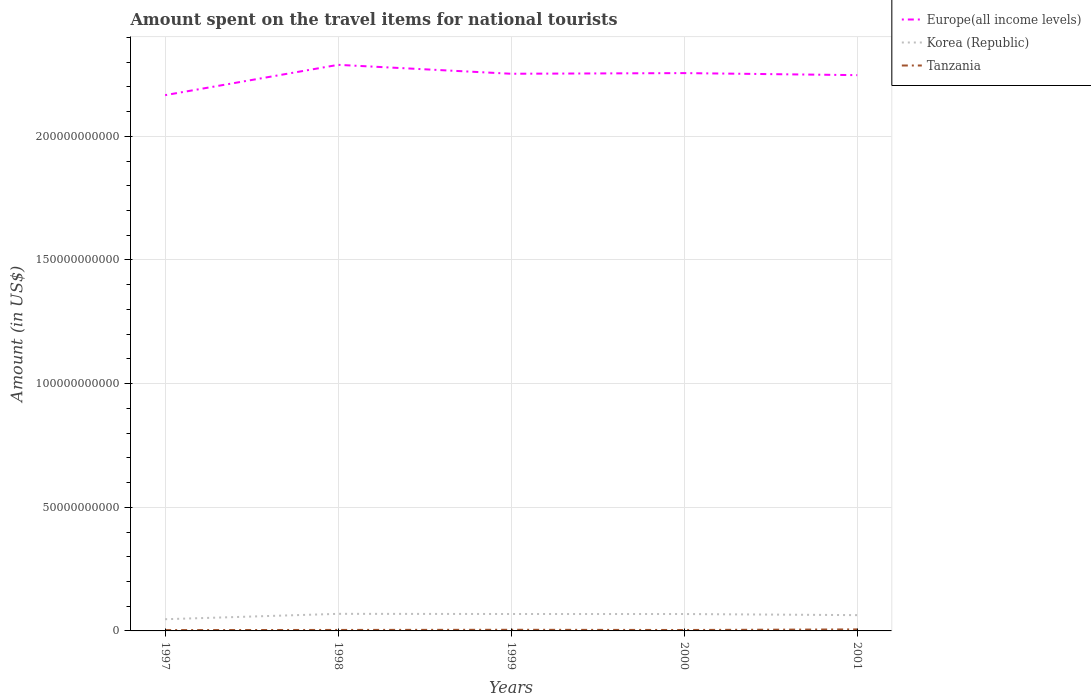Does the line corresponding to Korea (Republic) intersect with the line corresponding to Europe(all income levels)?
Your answer should be very brief. No. Is the number of lines equal to the number of legend labels?
Your answer should be compact. Yes. Across all years, what is the maximum amount spent on the travel items for national tourists in Tanzania?
Keep it short and to the point. 3.39e+08. In which year was the amount spent on the travel items for national tourists in Korea (Republic) maximum?
Provide a succinct answer. 1997. What is the total amount spent on the travel items for national tourists in Tanzania in the graph?
Ensure brevity in your answer.  -1.51e+08. What is the difference between the highest and the second highest amount spent on the travel items for national tourists in Korea (Republic)?
Make the answer very short. 2.18e+09. How many lines are there?
Your response must be concise. 3. What is the difference between two consecutive major ticks on the Y-axis?
Offer a very short reply. 5.00e+1. Are the values on the major ticks of Y-axis written in scientific E-notation?
Offer a terse response. No. Does the graph contain grids?
Provide a short and direct response. Yes. How are the legend labels stacked?
Give a very brief answer. Vertical. What is the title of the graph?
Offer a very short reply. Amount spent on the travel items for national tourists. Does "Slovenia" appear as one of the legend labels in the graph?
Provide a succinct answer. No. What is the Amount (in US$) of Europe(all income levels) in 1997?
Your response must be concise. 2.17e+11. What is the Amount (in US$) of Korea (Republic) in 1997?
Ensure brevity in your answer.  4.73e+09. What is the Amount (in US$) in Tanzania in 1997?
Make the answer very short. 3.39e+08. What is the Amount (in US$) of Europe(all income levels) in 1998?
Offer a very short reply. 2.29e+11. What is the Amount (in US$) in Korea (Republic) in 1998?
Your answer should be very brief. 6.91e+09. What is the Amount (in US$) in Tanzania in 1998?
Your answer should be compact. 3.99e+08. What is the Amount (in US$) in Europe(all income levels) in 1999?
Offer a terse response. 2.25e+11. What is the Amount (in US$) of Korea (Republic) in 1999?
Offer a very short reply. 6.84e+09. What is the Amount (in US$) in Tanzania in 1999?
Provide a short and direct response. 4.64e+08. What is the Amount (in US$) of Europe(all income levels) in 2000?
Offer a very short reply. 2.26e+11. What is the Amount (in US$) of Korea (Republic) in 2000?
Your response must be concise. 6.83e+09. What is the Amount (in US$) in Tanzania in 2000?
Offer a very short reply. 3.77e+08. What is the Amount (in US$) in Europe(all income levels) in 2001?
Ensure brevity in your answer.  2.25e+11. What is the Amount (in US$) in Korea (Republic) in 2001?
Your answer should be very brief. 6.38e+09. What is the Amount (in US$) in Tanzania in 2001?
Keep it short and to the point. 6.15e+08. Across all years, what is the maximum Amount (in US$) of Europe(all income levels)?
Ensure brevity in your answer.  2.29e+11. Across all years, what is the maximum Amount (in US$) in Korea (Republic)?
Your answer should be very brief. 6.91e+09. Across all years, what is the maximum Amount (in US$) in Tanzania?
Offer a very short reply. 6.15e+08. Across all years, what is the minimum Amount (in US$) of Europe(all income levels)?
Keep it short and to the point. 2.17e+11. Across all years, what is the minimum Amount (in US$) in Korea (Republic)?
Your response must be concise. 4.73e+09. Across all years, what is the minimum Amount (in US$) in Tanzania?
Your answer should be very brief. 3.39e+08. What is the total Amount (in US$) of Europe(all income levels) in the graph?
Offer a very short reply. 1.12e+12. What is the total Amount (in US$) in Korea (Republic) in the graph?
Offer a very short reply. 3.17e+1. What is the total Amount (in US$) in Tanzania in the graph?
Offer a very short reply. 2.19e+09. What is the difference between the Amount (in US$) of Europe(all income levels) in 1997 and that in 1998?
Offer a terse response. -1.23e+1. What is the difference between the Amount (in US$) of Korea (Republic) in 1997 and that in 1998?
Offer a very short reply. -2.18e+09. What is the difference between the Amount (in US$) of Tanzania in 1997 and that in 1998?
Provide a succinct answer. -6.00e+07. What is the difference between the Amount (in US$) of Europe(all income levels) in 1997 and that in 1999?
Offer a terse response. -8.65e+09. What is the difference between the Amount (in US$) of Korea (Republic) in 1997 and that in 1999?
Offer a very short reply. -2.11e+09. What is the difference between the Amount (in US$) of Tanzania in 1997 and that in 1999?
Provide a short and direct response. -1.25e+08. What is the difference between the Amount (in US$) in Europe(all income levels) in 1997 and that in 2000?
Your response must be concise. -8.92e+09. What is the difference between the Amount (in US$) in Korea (Republic) in 1997 and that in 2000?
Provide a short and direct response. -2.10e+09. What is the difference between the Amount (in US$) of Tanzania in 1997 and that in 2000?
Your answer should be compact. -3.80e+07. What is the difference between the Amount (in US$) of Europe(all income levels) in 1997 and that in 2001?
Offer a terse response. -8.09e+09. What is the difference between the Amount (in US$) in Korea (Republic) in 1997 and that in 2001?
Keep it short and to the point. -1.65e+09. What is the difference between the Amount (in US$) in Tanzania in 1997 and that in 2001?
Your response must be concise. -2.76e+08. What is the difference between the Amount (in US$) of Europe(all income levels) in 1998 and that in 1999?
Provide a succinct answer. 3.61e+09. What is the difference between the Amount (in US$) of Korea (Republic) in 1998 and that in 1999?
Provide a succinct answer. 6.70e+07. What is the difference between the Amount (in US$) of Tanzania in 1998 and that in 1999?
Keep it short and to the point. -6.50e+07. What is the difference between the Amount (in US$) in Europe(all income levels) in 1998 and that in 2000?
Offer a very short reply. 3.34e+09. What is the difference between the Amount (in US$) of Korea (Republic) in 1998 and that in 2000?
Give a very brief answer. 7.40e+07. What is the difference between the Amount (in US$) of Tanzania in 1998 and that in 2000?
Ensure brevity in your answer.  2.20e+07. What is the difference between the Amount (in US$) of Europe(all income levels) in 1998 and that in 2001?
Ensure brevity in your answer.  4.17e+09. What is the difference between the Amount (in US$) of Korea (Republic) in 1998 and that in 2001?
Keep it short and to the point. 5.24e+08. What is the difference between the Amount (in US$) in Tanzania in 1998 and that in 2001?
Give a very brief answer. -2.16e+08. What is the difference between the Amount (in US$) of Europe(all income levels) in 1999 and that in 2000?
Make the answer very short. -2.67e+08. What is the difference between the Amount (in US$) of Korea (Republic) in 1999 and that in 2000?
Your answer should be very brief. 7.00e+06. What is the difference between the Amount (in US$) in Tanzania in 1999 and that in 2000?
Offer a very short reply. 8.70e+07. What is the difference between the Amount (in US$) in Europe(all income levels) in 1999 and that in 2001?
Ensure brevity in your answer.  5.62e+08. What is the difference between the Amount (in US$) in Korea (Republic) in 1999 and that in 2001?
Offer a terse response. 4.57e+08. What is the difference between the Amount (in US$) in Tanzania in 1999 and that in 2001?
Provide a short and direct response. -1.51e+08. What is the difference between the Amount (in US$) in Europe(all income levels) in 2000 and that in 2001?
Your answer should be very brief. 8.29e+08. What is the difference between the Amount (in US$) of Korea (Republic) in 2000 and that in 2001?
Make the answer very short. 4.50e+08. What is the difference between the Amount (in US$) of Tanzania in 2000 and that in 2001?
Ensure brevity in your answer.  -2.38e+08. What is the difference between the Amount (in US$) of Europe(all income levels) in 1997 and the Amount (in US$) of Korea (Republic) in 1998?
Keep it short and to the point. 2.10e+11. What is the difference between the Amount (in US$) in Europe(all income levels) in 1997 and the Amount (in US$) in Tanzania in 1998?
Give a very brief answer. 2.16e+11. What is the difference between the Amount (in US$) in Korea (Republic) in 1997 and the Amount (in US$) in Tanzania in 1998?
Give a very brief answer. 4.33e+09. What is the difference between the Amount (in US$) of Europe(all income levels) in 1997 and the Amount (in US$) of Korea (Republic) in 1999?
Provide a succinct answer. 2.10e+11. What is the difference between the Amount (in US$) of Europe(all income levels) in 1997 and the Amount (in US$) of Tanzania in 1999?
Make the answer very short. 2.16e+11. What is the difference between the Amount (in US$) in Korea (Republic) in 1997 and the Amount (in US$) in Tanzania in 1999?
Ensure brevity in your answer.  4.27e+09. What is the difference between the Amount (in US$) of Europe(all income levels) in 1997 and the Amount (in US$) of Korea (Republic) in 2000?
Make the answer very short. 2.10e+11. What is the difference between the Amount (in US$) in Europe(all income levels) in 1997 and the Amount (in US$) in Tanzania in 2000?
Offer a very short reply. 2.16e+11. What is the difference between the Amount (in US$) in Korea (Republic) in 1997 and the Amount (in US$) in Tanzania in 2000?
Provide a succinct answer. 4.35e+09. What is the difference between the Amount (in US$) of Europe(all income levels) in 1997 and the Amount (in US$) of Korea (Republic) in 2001?
Provide a succinct answer. 2.10e+11. What is the difference between the Amount (in US$) in Europe(all income levels) in 1997 and the Amount (in US$) in Tanzania in 2001?
Your answer should be compact. 2.16e+11. What is the difference between the Amount (in US$) in Korea (Republic) in 1997 and the Amount (in US$) in Tanzania in 2001?
Offer a terse response. 4.12e+09. What is the difference between the Amount (in US$) in Europe(all income levels) in 1998 and the Amount (in US$) in Korea (Republic) in 1999?
Make the answer very short. 2.22e+11. What is the difference between the Amount (in US$) in Europe(all income levels) in 1998 and the Amount (in US$) in Tanzania in 1999?
Provide a succinct answer. 2.28e+11. What is the difference between the Amount (in US$) of Korea (Republic) in 1998 and the Amount (in US$) of Tanzania in 1999?
Provide a short and direct response. 6.44e+09. What is the difference between the Amount (in US$) in Europe(all income levels) in 1998 and the Amount (in US$) in Korea (Republic) in 2000?
Provide a succinct answer. 2.22e+11. What is the difference between the Amount (in US$) in Europe(all income levels) in 1998 and the Amount (in US$) in Tanzania in 2000?
Make the answer very short. 2.29e+11. What is the difference between the Amount (in US$) of Korea (Republic) in 1998 and the Amount (in US$) of Tanzania in 2000?
Ensure brevity in your answer.  6.53e+09. What is the difference between the Amount (in US$) in Europe(all income levels) in 1998 and the Amount (in US$) in Korea (Republic) in 2001?
Keep it short and to the point. 2.23e+11. What is the difference between the Amount (in US$) of Europe(all income levels) in 1998 and the Amount (in US$) of Tanzania in 2001?
Make the answer very short. 2.28e+11. What is the difference between the Amount (in US$) of Korea (Republic) in 1998 and the Amount (in US$) of Tanzania in 2001?
Your response must be concise. 6.29e+09. What is the difference between the Amount (in US$) in Europe(all income levels) in 1999 and the Amount (in US$) in Korea (Republic) in 2000?
Your answer should be very brief. 2.18e+11. What is the difference between the Amount (in US$) in Europe(all income levels) in 1999 and the Amount (in US$) in Tanzania in 2000?
Offer a very short reply. 2.25e+11. What is the difference between the Amount (in US$) in Korea (Republic) in 1999 and the Amount (in US$) in Tanzania in 2000?
Ensure brevity in your answer.  6.46e+09. What is the difference between the Amount (in US$) of Europe(all income levels) in 1999 and the Amount (in US$) of Korea (Republic) in 2001?
Offer a very short reply. 2.19e+11. What is the difference between the Amount (in US$) of Europe(all income levels) in 1999 and the Amount (in US$) of Tanzania in 2001?
Offer a very short reply. 2.25e+11. What is the difference between the Amount (in US$) in Korea (Republic) in 1999 and the Amount (in US$) in Tanzania in 2001?
Provide a short and direct response. 6.23e+09. What is the difference between the Amount (in US$) in Europe(all income levels) in 2000 and the Amount (in US$) in Korea (Republic) in 2001?
Keep it short and to the point. 2.19e+11. What is the difference between the Amount (in US$) of Europe(all income levels) in 2000 and the Amount (in US$) of Tanzania in 2001?
Your answer should be very brief. 2.25e+11. What is the difference between the Amount (in US$) in Korea (Republic) in 2000 and the Amount (in US$) in Tanzania in 2001?
Offer a very short reply. 6.22e+09. What is the average Amount (in US$) in Europe(all income levels) per year?
Your answer should be compact. 2.24e+11. What is the average Amount (in US$) in Korea (Republic) per year?
Offer a very short reply. 6.34e+09. What is the average Amount (in US$) of Tanzania per year?
Make the answer very short. 4.39e+08. In the year 1997, what is the difference between the Amount (in US$) in Europe(all income levels) and Amount (in US$) in Korea (Republic)?
Give a very brief answer. 2.12e+11. In the year 1997, what is the difference between the Amount (in US$) of Europe(all income levels) and Amount (in US$) of Tanzania?
Your response must be concise. 2.16e+11. In the year 1997, what is the difference between the Amount (in US$) in Korea (Republic) and Amount (in US$) in Tanzania?
Your answer should be compact. 4.39e+09. In the year 1998, what is the difference between the Amount (in US$) of Europe(all income levels) and Amount (in US$) of Korea (Republic)?
Provide a succinct answer. 2.22e+11. In the year 1998, what is the difference between the Amount (in US$) of Europe(all income levels) and Amount (in US$) of Tanzania?
Your answer should be very brief. 2.29e+11. In the year 1998, what is the difference between the Amount (in US$) of Korea (Republic) and Amount (in US$) of Tanzania?
Your answer should be compact. 6.51e+09. In the year 1999, what is the difference between the Amount (in US$) of Europe(all income levels) and Amount (in US$) of Korea (Republic)?
Ensure brevity in your answer.  2.18e+11. In the year 1999, what is the difference between the Amount (in US$) of Europe(all income levels) and Amount (in US$) of Tanzania?
Make the answer very short. 2.25e+11. In the year 1999, what is the difference between the Amount (in US$) of Korea (Republic) and Amount (in US$) of Tanzania?
Give a very brief answer. 6.38e+09. In the year 2000, what is the difference between the Amount (in US$) in Europe(all income levels) and Amount (in US$) in Korea (Republic)?
Provide a succinct answer. 2.19e+11. In the year 2000, what is the difference between the Amount (in US$) of Europe(all income levels) and Amount (in US$) of Tanzania?
Ensure brevity in your answer.  2.25e+11. In the year 2000, what is the difference between the Amount (in US$) in Korea (Republic) and Amount (in US$) in Tanzania?
Your answer should be very brief. 6.46e+09. In the year 2001, what is the difference between the Amount (in US$) in Europe(all income levels) and Amount (in US$) in Korea (Republic)?
Your answer should be compact. 2.18e+11. In the year 2001, what is the difference between the Amount (in US$) in Europe(all income levels) and Amount (in US$) in Tanzania?
Provide a short and direct response. 2.24e+11. In the year 2001, what is the difference between the Amount (in US$) in Korea (Republic) and Amount (in US$) in Tanzania?
Ensure brevity in your answer.  5.77e+09. What is the ratio of the Amount (in US$) in Europe(all income levels) in 1997 to that in 1998?
Your answer should be very brief. 0.95. What is the ratio of the Amount (in US$) of Korea (Republic) in 1997 to that in 1998?
Ensure brevity in your answer.  0.68. What is the ratio of the Amount (in US$) of Tanzania in 1997 to that in 1998?
Ensure brevity in your answer.  0.85. What is the ratio of the Amount (in US$) of Europe(all income levels) in 1997 to that in 1999?
Your response must be concise. 0.96. What is the ratio of the Amount (in US$) of Korea (Republic) in 1997 to that in 1999?
Ensure brevity in your answer.  0.69. What is the ratio of the Amount (in US$) of Tanzania in 1997 to that in 1999?
Ensure brevity in your answer.  0.73. What is the ratio of the Amount (in US$) of Europe(all income levels) in 1997 to that in 2000?
Offer a very short reply. 0.96. What is the ratio of the Amount (in US$) in Korea (Republic) in 1997 to that in 2000?
Your answer should be very brief. 0.69. What is the ratio of the Amount (in US$) in Tanzania in 1997 to that in 2000?
Provide a short and direct response. 0.9. What is the ratio of the Amount (in US$) in Korea (Republic) in 1997 to that in 2001?
Ensure brevity in your answer.  0.74. What is the ratio of the Amount (in US$) of Tanzania in 1997 to that in 2001?
Make the answer very short. 0.55. What is the ratio of the Amount (in US$) in Europe(all income levels) in 1998 to that in 1999?
Your answer should be compact. 1.02. What is the ratio of the Amount (in US$) of Korea (Republic) in 1998 to that in 1999?
Offer a terse response. 1.01. What is the ratio of the Amount (in US$) in Tanzania in 1998 to that in 1999?
Make the answer very short. 0.86. What is the ratio of the Amount (in US$) of Europe(all income levels) in 1998 to that in 2000?
Give a very brief answer. 1.01. What is the ratio of the Amount (in US$) in Korea (Republic) in 1998 to that in 2000?
Provide a succinct answer. 1.01. What is the ratio of the Amount (in US$) of Tanzania in 1998 to that in 2000?
Your answer should be compact. 1.06. What is the ratio of the Amount (in US$) of Europe(all income levels) in 1998 to that in 2001?
Make the answer very short. 1.02. What is the ratio of the Amount (in US$) in Korea (Republic) in 1998 to that in 2001?
Ensure brevity in your answer.  1.08. What is the ratio of the Amount (in US$) in Tanzania in 1998 to that in 2001?
Provide a succinct answer. 0.65. What is the ratio of the Amount (in US$) in Europe(all income levels) in 1999 to that in 2000?
Offer a terse response. 1. What is the ratio of the Amount (in US$) in Tanzania in 1999 to that in 2000?
Ensure brevity in your answer.  1.23. What is the ratio of the Amount (in US$) of Europe(all income levels) in 1999 to that in 2001?
Ensure brevity in your answer.  1. What is the ratio of the Amount (in US$) in Korea (Republic) in 1999 to that in 2001?
Provide a succinct answer. 1.07. What is the ratio of the Amount (in US$) of Tanzania in 1999 to that in 2001?
Provide a short and direct response. 0.75. What is the ratio of the Amount (in US$) in Europe(all income levels) in 2000 to that in 2001?
Provide a succinct answer. 1. What is the ratio of the Amount (in US$) in Korea (Republic) in 2000 to that in 2001?
Your answer should be compact. 1.07. What is the ratio of the Amount (in US$) of Tanzania in 2000 to that in 2001?
Offer a terse response. 0.61. What is the difference between the highest and the second highest Amount (in US$) in Europe(all income levels)?
Your response must be concise. 3.34e+09. What is the difference between the highest and the second highest Amount (in US$) of Korea (Republic)?
Your answer should be compact. 6.70e+07. What is the difference between the highest and the second highest Amount (in US$) in Tanzania?
Your response must be concise. 1.51e+08. What is the difference between the highest and the lowest Amount (in US$) of Europe(all income levels)?
Keep it short and to the point. 1.23e+1. What is the difference between the highest and the lowest Amount (in US$) of Korea (Republic)?
Give a very brief answer. 2.18e+09. What is the difference between the highest and the lowest Amount (in US$) of Tanzania?
Ensure brevity in your answer.  2.76e+08. 